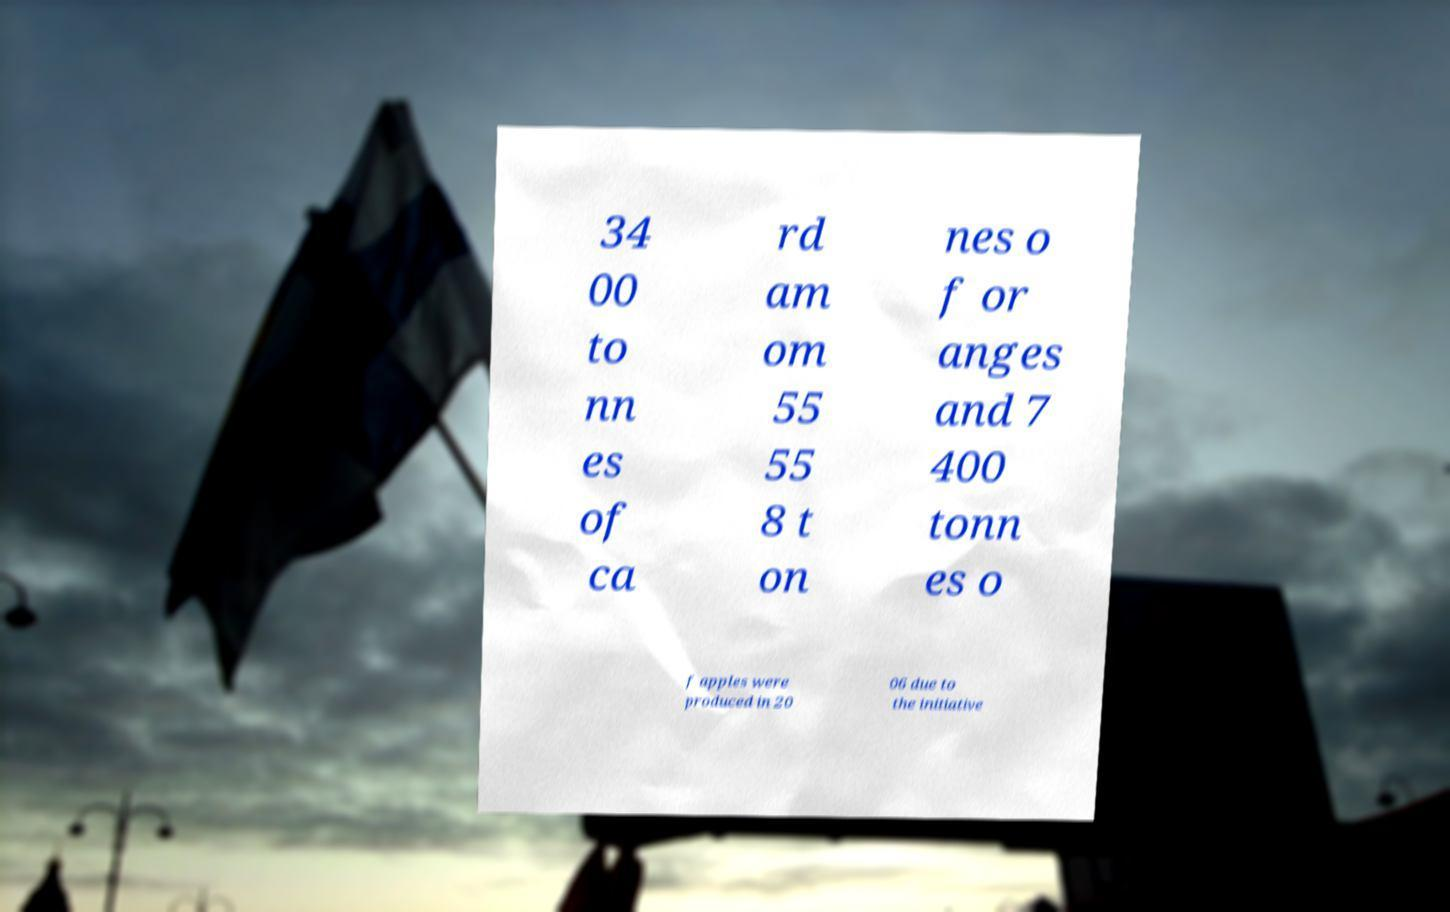Could you assist in decoding the text presented in this image and type it out clearly? 34 00 to nn es of ca rd am om 55 55 8 t on nes o f or anges and 7 400 tonn es o f apples were produced in 20 06 due to the initiative 